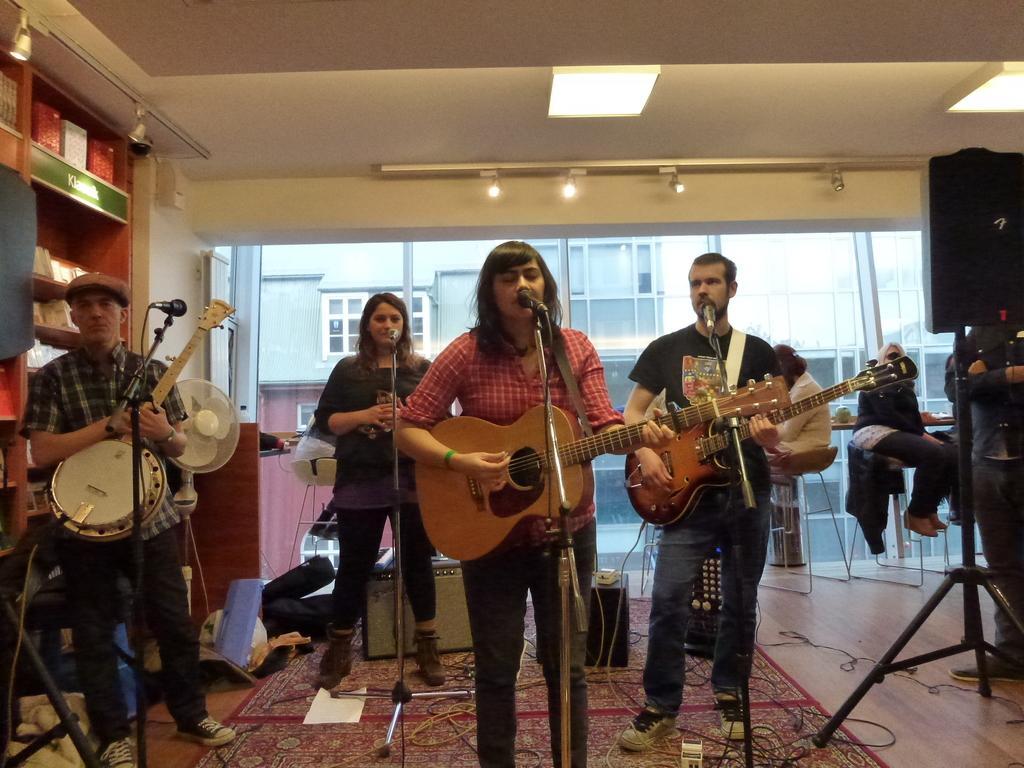Could you give a brief overview of what you see in this image? As we can see in the image there is a wall, shelf, a building. On the right side there is a sound box and few people sitting and there are four people standing. Among them three of them are holding guitars. In front of them there are mics and the woman who is standing here is singing a song. On the left side there is a table fan. 